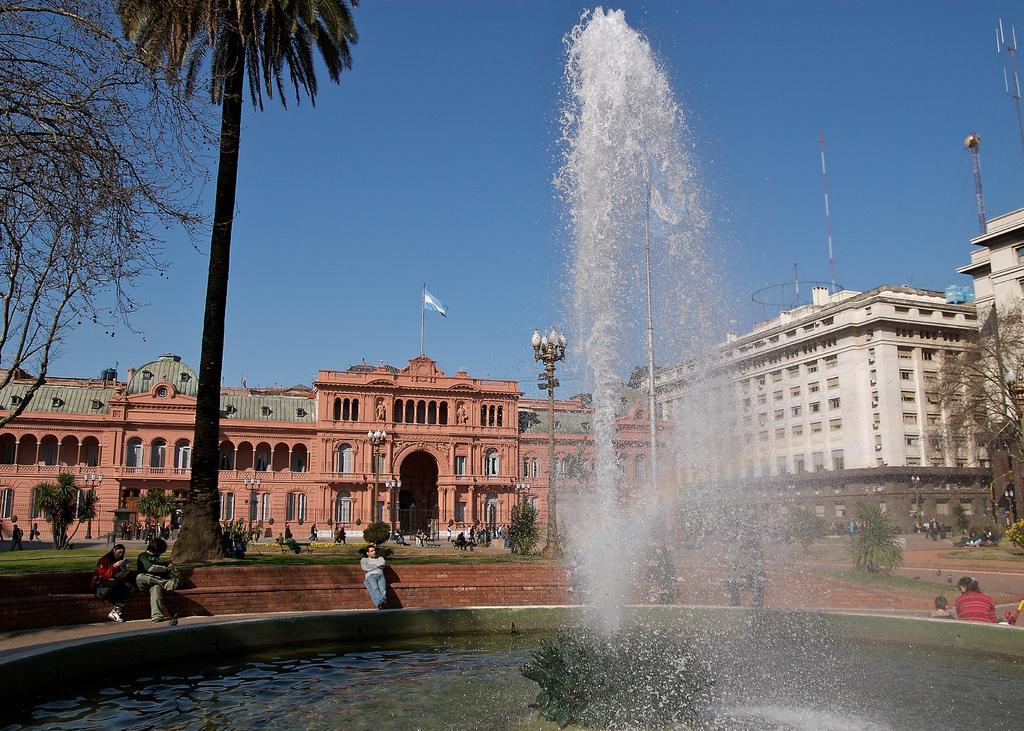Can you describe this image briefly? In this image I can see in the middle a water fountain, on the left side few people are sitting, there are trees. At the back side there are buildings, at the top it is the sky. 